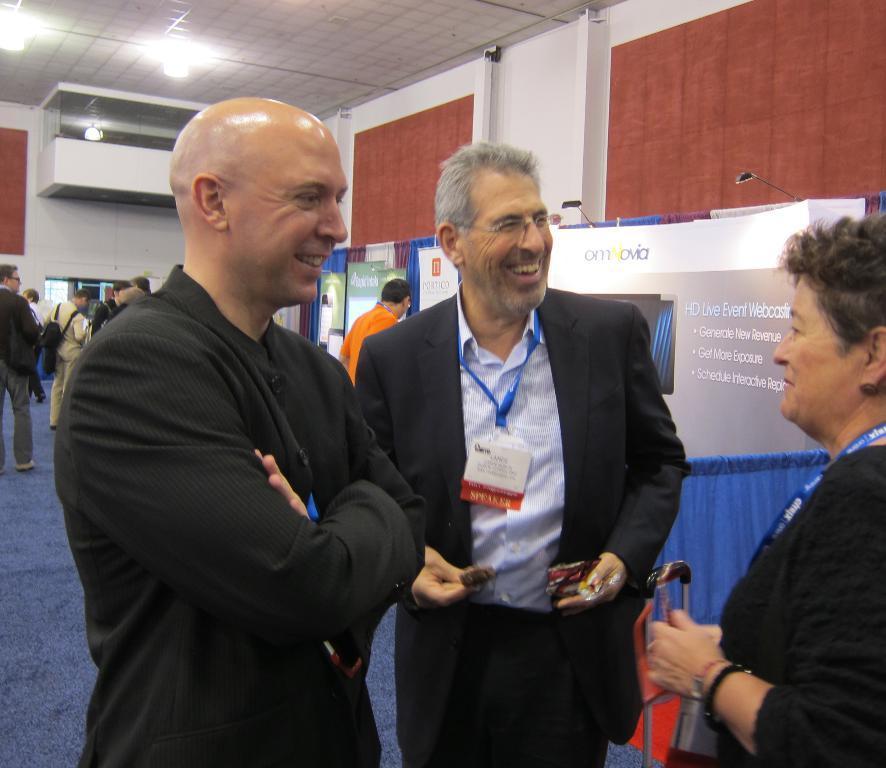In one or two sentences, can you explain what this image depicts? In this picture I can see there are three people standing here and they are smiling and there are banners and a wall in the backdrop and there are lights attached to the ceiling. 